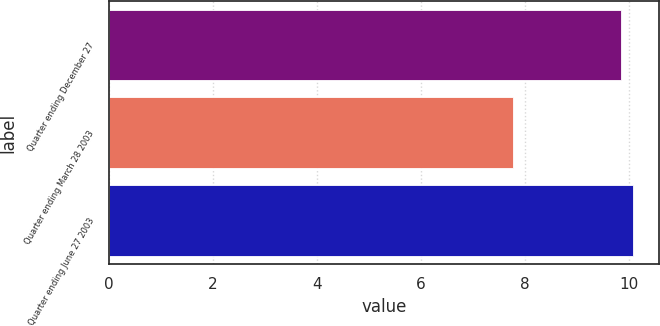<chart> <loc_0><loc_0><loc_500><loc_500><bar_chart><fcel>Quarter ending December 27<fcel>Quarter ending March 28 2003<fcel>Quarter ending June 27 2003<nl><fcel>9.86<fcel>7.78<fcel>10.08<nl></chart> 